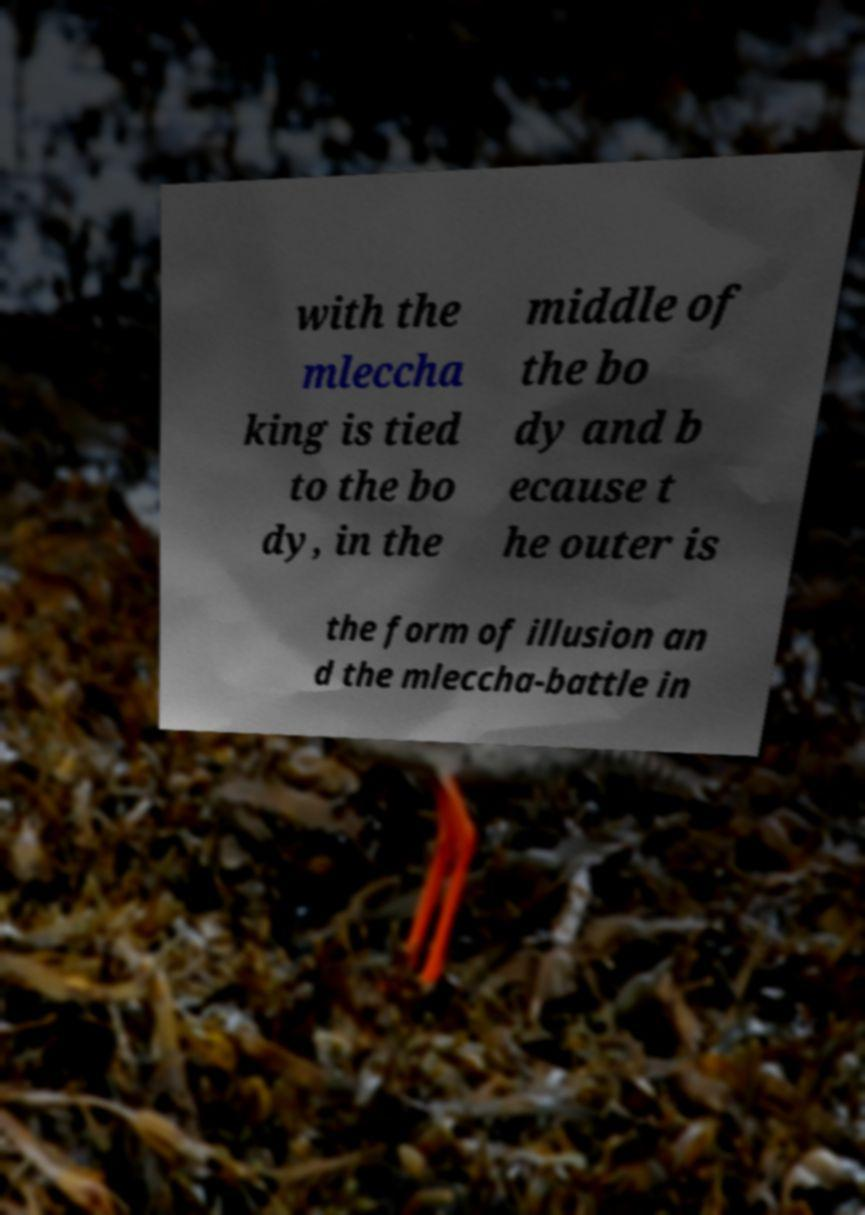Could you assist in decoding the text presented in this image and type it out clearly? with the mleccha king is tied to the bo dy, in the middle of the bo dy and b ecause t he outer is the form of illusion an d the mleccha-battle in 